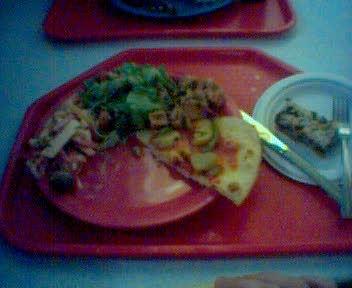The tray is pink in color?
Give a very brief answer. Yes. What is the color of the plate?
Concise answer only. Red. What surface is the lunch sitting atop?
Keep it brief. Tray. Has any of this food been cooked?
Short answer required. Yes. Is the food eaten?
Write a very short answer. Yes. Are there any vegetables?
Short answer required. Yes. Is this a bowl of salad?
Give a very brief answer. No. Are these plates?
Short answer required. Yes. What eating utensil is on the tray?
Write a very short answer. Knife and fork. How many pizzas are there?
Keep it brief. 1. What type of meat is shown?
Concise answer only. Beef. What is on the plate?
Be succinct. Pizza. What color is the tray?
Short answer required. Red. 